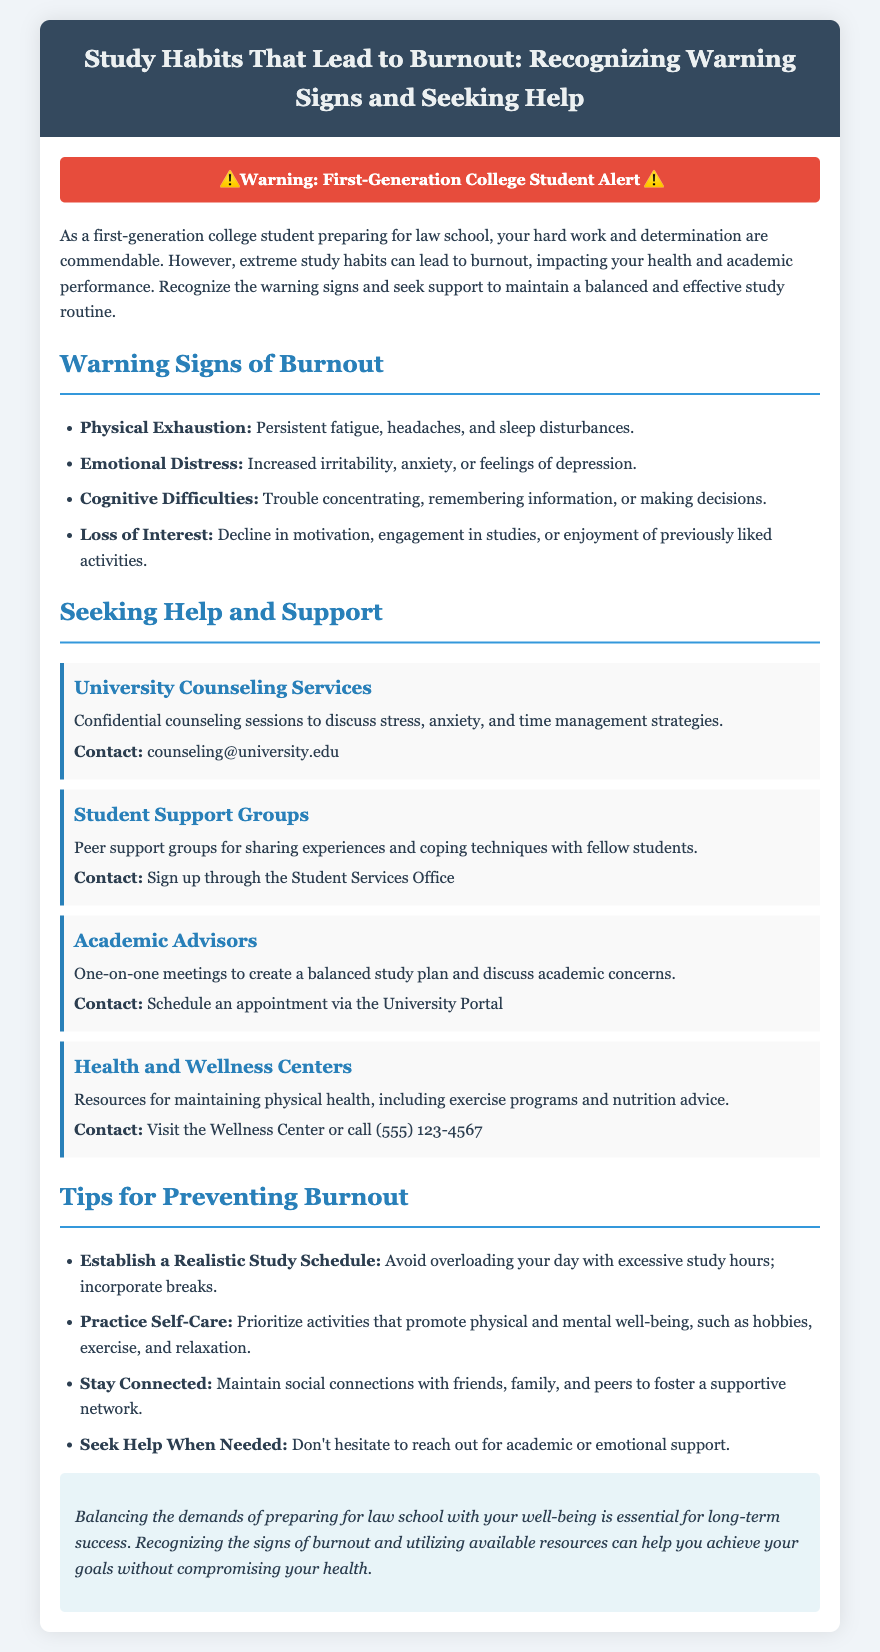What are two physical symptoms of burnout? The document lists physical exhaustion as a symptom, including persistent fatigue and sleep disturbances.
Answer: Persistent fatigue, sleep disturbances What is the contact for University Counseling Services? The document provides the email contact for University Counseling Services, which is listed under that section.
Answer: counseling@university.edu How many tips are provided for preventing burnout? The section on tips lists four distinct strategies for preventing burnout.
Answer: Four What type of resource is available at Health and Wellness Centers? The document states that Health and Wellness Centers provide resources for maintaining physical health.
Answer: Physical health resources Which emotional symptoms indicate burnout? Increased irritability, anxiety, or feelings of depression are listed as emotional symptoms of burnout in the document.
Answer: Increased irritability, anxiety, feelings of depression What should you do if you recognize signs of burnout? The document advises seeking help when needed if burnout signs are recognized.
Answer: Seek help 